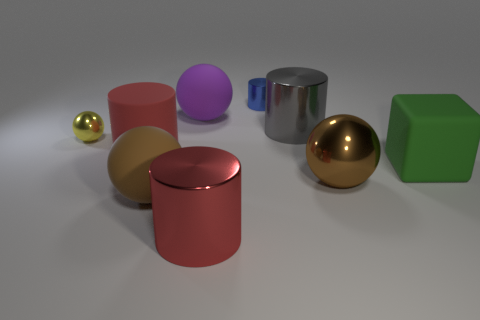What can you infer about the source of lighting in this scene? The lighting in the scene appears to be diffused, with subtle shadows indicating that the light source may be large and possibly located above the objects. There are no harsh shadows or highlights, which suggests an indirect or ambient light source, giving the scene a soft and even illumination. 